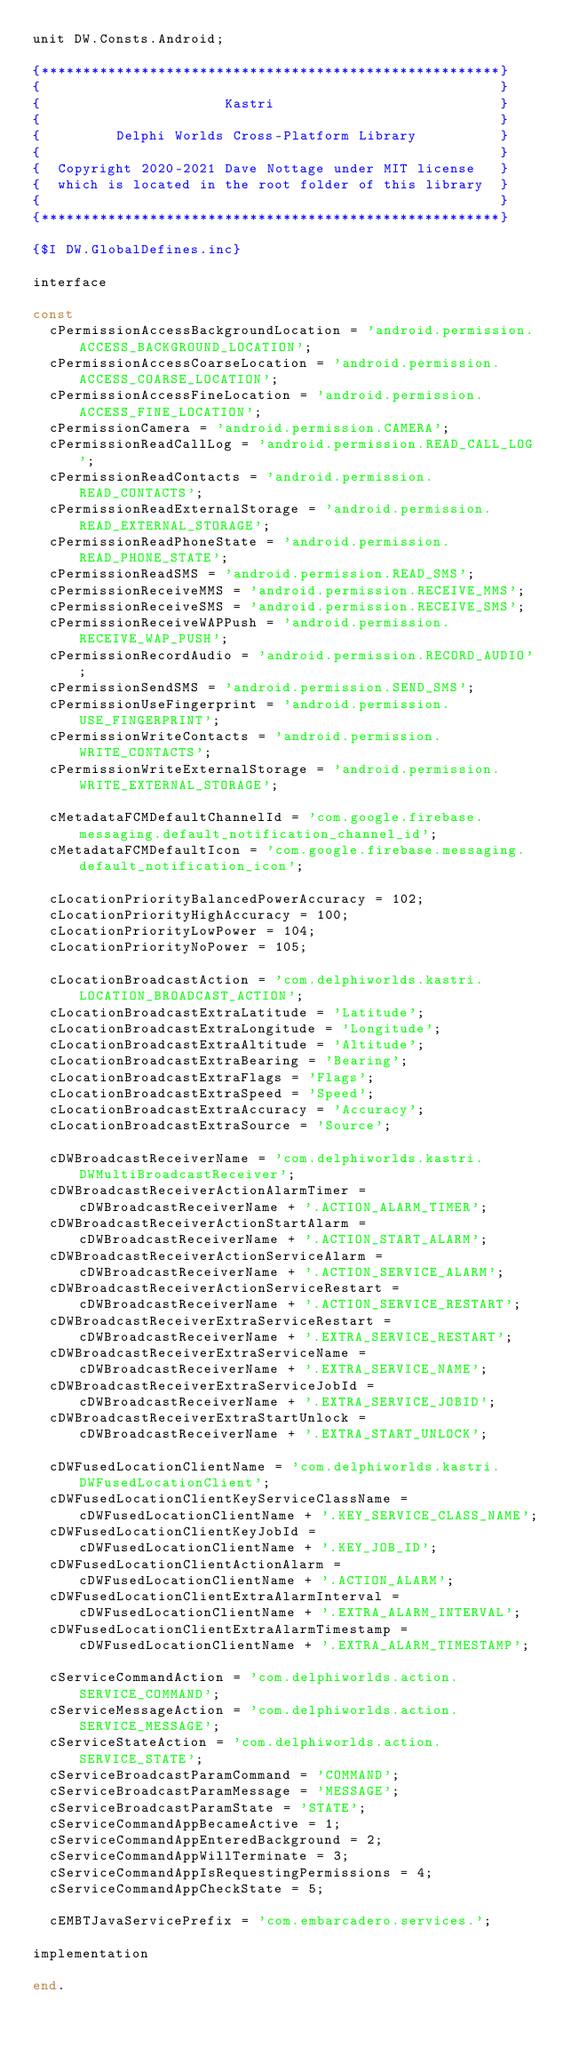Convert code to text. <code><loc_0><loc_0><loc_500><loc_500><_Pascal_>unit DW.Consts.Android;

{*******************************************************}
{                                                       }
{                      Kastri                           }
{                                                       }
{         Delphi Worlds Cross-Platform Library          }
{                                                       }
{  Copyright 2020-2021 Dave Nottage under MIT license   }
{  which is located in the root folder of this library  }
{                                                       }
{*******************************************************}

{$I DW.GlobalDefines.inc}

interface

const
  cPermissionAccessBackgroundLocation = 'android.permission.ACCESS_BACKGROUND_LOCATION';
  cPermissionAccessCoarseLocation = 'android.permission.ACCESS_COARSE_LOCATION';
  cPermissionAccessFineLocation = 'android.permission.ACCESS_FINE_LOCATION';
  cPermissionCamera = 'android.permission.CAMERA';
  cPermissionReadCallLog = 'android.permission.READ_CALL_LOG';
  cPermissionReadContacts = 'android.permission.READ_CONTACTS';
  cPermissionReadExternalStorage = 'android.permission.READ_EXTERNAL_STORAGE';
  cPermissionReadPhoneState = 'android.permission.READ_PHONE_STATE';
  cPermissionReadSMS = 'android.permission.READ_SMS';
  cPermissionReceiveMMS = 'android.permission.RECEIVE_MMS';
  cPermissionReceiveSMS = 'android.permission.RECEIVE_SMS';
  cPermissionReceiveWAPPush = 'android.permission.RECEIVE_WAP_PUSH';
  cPermissionRecordAudio = 'android.permission.RECORD_AUDIO';
  cPermissionSendSMS = 'android.permission.SEND_SMS';
  cPermissionUseFingerprint = 'android.permission.USE_FINGERPRINT';
  cPermissionWriteContacts = 'android.permission.WRITE_CONTACTS';
  cPermissionWriteExternalStorage = 'android.permission.WRITE_EXTERNAL_STORAGE';

  cMetadataFCMDefaultChannelId = 'com.google.firebase.messaging.default_notification_channel_id';
  cMetadataFCMDefaultIcon = 'com.google.firebase.messaging.default_notification_icon';

  cLocationPriorityBalancedPowerAccuracy = 102;
  cLocationPriorityHighAccuracy = 100;
  cLocationPriorityLowPower = 104;
  cLocationPriorityNoPower = 105;

  cLocationBroadcastAction = 'com.delphiworlds.kastri.LOCATION_BROADCAST_ACTION';
  cLocationBroadcastExtraLatitude = 'Latitude';
  cLocationBroadcastExtraLongitude = 'Longitude';
  cLocationBroadcastExtraAltitude = 'Altitude';
  cLocationBroadcastExtraBearing = 'Bearing';
  cLocationBroadcastExtraFlags = 'Flags';
  cLocationBroadcastExtraSpeed = 'Speed';
  cLocationBroadcastExtraAccuracy = 'Accuracy';
  cLocationBroadcastExtraSource = 'Source';

  cDWBroadcastReceiverName = 'com.delphiworlds.kastri.DWMultiBroadcastReceiver';
  cDWBroadcastReceiverActionAlarmTimer = cDWBroadcastReceiverName + '.ACTION_ALARM_TIMER';
  cDWBroadcastReceiverActionStartAlarm = cDWBroadcastReceiverName + '.ACTION_START_ALARM';
  cDWBroadcastReceiverActionServiceAlarm = cDWBroadcastReceiverName + '.ACTION_SERVICE_ALARM';
  cDWBroadcastReceiverActionServiceRestart = cDWBroadcastReceiverName + '.ACTION_SERVICE_RESTART';
  cDWBroadcastReceiverExtraServiceRestart = cDWBroadcastReceiverName + '.EXTRA_SERVICE_RESTART';
  cDWBroadcastReceiverExtraServiceName = cDWBroadcastReceiverName + '.EXTRA_SERVICE_NAME';
  cDWBroadcastReceiverExtraServiceJobId = cDWBroadcastReceiverName + '.EXTRA_SERVICE_JOBID';
  cDWBroadcastReceiverExtraStartUnlock = cDWBroadcastReceiverName + '.EXTRA_START_UNLOCK';

  cDWFusedLocationClientName = 'com.delphiworlds.kastri.DWFusedLocationClient';
  cDWFusedLocationClientKeyServiceClassName = cDWFusedLocationClientName + '.KEY_SERVICE_CLASS_NAME';
  cDWFusedLocationClientKeyJobId = cDWFusedLocationClientName + '.KEY_JOB_ID';
  cDWFusedLocationClientActionAlarm = cDWFusedLocationClientName + '.ACTION_ALARM';
  cDWFusedLocationClientExtraAlarmInterval = cDWFusedLocationClientName + '.EXTRA_ALARM_INTERVAL';
  cDWFusedLocationClientExtraAlarmTimestamp = cDWFusedLocationClientName + '.EXTRA_ALARM_TIMESTAMP';

  cServiceCommandAction = 'com.delphiworlds.action.SERVICE_COMMAND';
  cServiceMessageAction = 'com.delphiworlds.action.SERVICE_MESSAGE';
  cServiceStateAction = 'com.delphiworlds.action.SERVICE_STATE';
  cServiceBroadcastParamCommand = 'COMMAND';
  cServiceBroadcastParamMessage = 'MESSAGE';
  cServiceBroadcastParamState = 'STATE';
  cServiceCommandAppBecameActive = 1;
  cServiceCommandAppEnteredBackground = 2;
  cServiceCommandAppWillTerminate = 3;
  cServiceCommandAppIsRequestingPermissions = 4;
  cServiceCommandAppCheckState = 5;

  cEMBTJavaServicePrefix = 'com.embarcadero.services.';

implementation

end.
</code> 